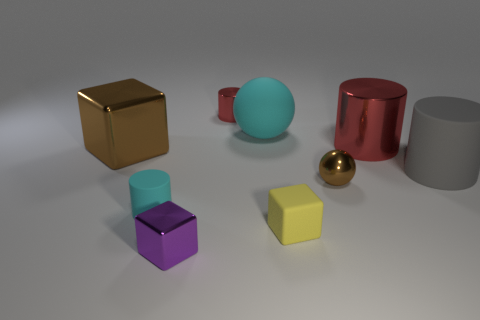Subtract all small rubber cylinders. How many cylinders are left? 3 Subtract all purple cylinders. Subtract all red blocks. How many cylinders are left? 4 Subtract all cylinders. How many objects are left? 5 Add 1 large cyan balls. How many objects exist? 10 Subtract all tiny cylinders. Subtract all tiny objects. How many objects are left? 2 Add 2 large rubber things. How many large rubber things are left? 4 Add 5 large brown balls. How many large brown balls exist? 5 Subtract 0 yellow cylinders. How many objects are left? 9 